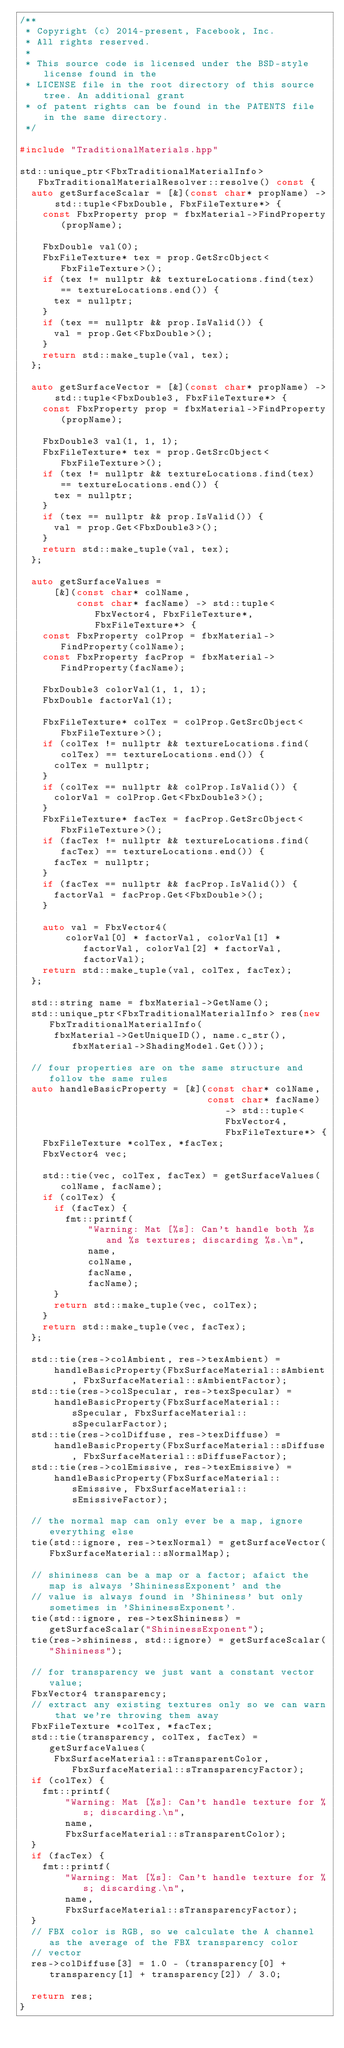Convert code to text. <code><loc_0><loc_0><loc_500><loc_500><_C++_>/**
 * Copyright (c) 2014-present, Facebook, Inc.
 * All rights reserved.
 *
 * This source code is licensed under the BSD-style license found in the
 * LICENSE file in the root directory of this source tree. An additional grant
 * of patent rights can be found in the PATENTS file in the same directory.
 */

#include "TraditionalMaterials.hpp"

std::unique_ptr<FbxTraditionalMaterialInfo> FbxTraditionalMaterialResolver::resolve() const {
  auto getSurfaceScalar = [&](const char* propName) -> std::tuple<FbxDouble, FbxFileTexture*> {
    const FbxProperty prop = fbxMaterial->FindProperty(propName);

    FbxDouble val(0);
    FbxFileTexture* tex = prop.GetSrcObject<FbxFileTexture>();
    if (tex != nullptr && textureLocations.find(tex) == textureLocations.end()) {
      tex = nullptr;
    }
    if (tex == nullptr && prop.IsValid()) {
      val = prop.Get<FbxDouble>();
    }
    return std::make_tuple(val, tex);
  };

  auto getSurfaceVector = [&](const char* propName) -> std::tuple<FbxDouble3, FbxFileTexture*> {
    const FbxProperty prop = fbxMaterial->FindProperty(propName);

    FbxDouble3 val(1, 1, 1);
    FbxFileTexture* tex = prop.GetSrcObject<FbxFileTexture>();
    if (tex != nullptr && textureLocations.find(tex) == textureLocations.end()) {
      tex = nullptr;
    }
    if (tex == nullptr && prop.IsValid()) {
      val = prop.Get<FbxDouble3>();
    }
    return std::make_tuple(val, tex);
  };

  auto getSurfaceValues =
      [&](const char* colName,
          const char* facName) -> std::tuple<FbxVector4, FbxFileTexture*, FbxFileTexture*> {
    const FbxProperty colProp = fbxMaterial->FindProperty(colName);
    const FbxProperty facProp = fbxMaterial->FindProperty(facName);

    FbxDouble3 colorVal(1, 1, 1);
    FbxDouble factorVal(1);

    FbxFileTexture* colTex = colProp.GetSrcObject<FbxFileTexture>();
    if (colTex != nullptr && textureLocations.find(colTex) == textureLocations.end()) {
      colTex = nullptr;
    }
    if (colTex == nullptr && colProp.IsValid()) {
      colorVal = colProp.Get<FbxDouble3>();
    }
    FbxFileTexture* facTex = facProp.GetSrcObject<FbxFileTexture>();
    if (facTex != nullptr && textureLocations.find(facTex) == textureLocations.end()) {
      facTex = nullptr;
    }
    if (facTex == nullptr && facProp.IsValid()) {
      factorVal = facProp.Get<FbxDouble>();
    }

    auto val = FbxVector4(
        colorVal[0] * factorVal, colorVal[1] * factorVal, colorVal[2] * factorVal, factorVal);
    return std::make_tuple(val, colTex, facTex);
  };

  std::string name = fbxMaterial->GetName();
  std::unique_ptr<FbxTraditionalMaterialInfo> res(new FbxTraditionalMaterialInfo(
      fbxMaterial->GetUniqueID(), name.c_str(), fbxMaterial->ShadingModel.Get()));

  // four properties are on the same structure and follow the same rules
  auto handleBasicProperty = [&](const char* colName,
                                 const char* facName) -> std::tuple<FbxVector4, FbxFileTexture*> {
    FbxFileTexture *colTex, *facTex;
    FbxVector4 vec;

    std::tie(vec, colTex, facTex) = getSurfaceValues(colName, facName);
    if (colTex) {
      if (facTex) {
        fmt::printf(
            "Warning: Mat [%s]: Can't handle both %s and %s textures; discarding %s.\n",
            name,
            colName,
            facName,
            facName);
      }
      return std::make_tuple(vec, colTex);
    }
    return std::make_tuple(vec, facTex);
  };

  std::tie(res->colAmbient, res->texAmbient) =
      handleBasicProperty(FbxSurfaceMaterial::sAmbient, FbxSurfaceMaterial::sAmbientFactor);
  std::tie(res->colSpecular, res->texSpecular) =
      handleBasicProperty(FbxSurfaceMaterial::sSpecular, FbxSurfaceMaterial::sSpecularFactor);
  std::tie(res->colDiffuse, res->texDiffuse) =
      handleBasicProperty(FbxSurfaceMaterial::sDiffuse, FbxSurfaceMaterial::sDiffuseFactor);
  std::tie(res->colEmissive, res->texEmissive) =
      handleBasicProperty(FbxSurfaceMaterial::sEmissive, FbxSurfaceMaterial::sEmissiveFactor);

  // the normal map can only ever be a map, ignore everything else
  tie(std::ignore, res->texNormal) = getSurfaceVector(FbxSurfaceMaterial::sNormalMap);

  // shininess can be a map or a factor; afaict the map is always 'ShininessExponent' and the
  // value is always found in 'Shininess' but only sometimes in 'ShininessExponent'.
  tie(std::ignore, res->texShininess) = getSurfaceScalar("ShininessExponent");
  tie(res->shininess, std::ignore) = getSurfaceScalar("Shininess");

  // for transparency we just want a constant vector value;
  FbxVector4 transparency;
  // extract any existing textures only so we can warn that we're throwing them away
  FbxFileTexture *colTex, *facTex;
  std::tie(transparency, colTex, facTex) = getSurfaceValues(
      FbxSurfaceMaterial::sTransparentColor, FbxSurfaceMaterial::sTransparencyFactor);
  if (colTex) {
    fmt::printf(
        "Warning: Mat [%s]: Can't handle texture for %s; discarding.\n",
        name,
        FbxSurfaceMaterial::sTransparentColor);
  }
  if (facTex) {
    fmt::printf(
        "Warning: Mat [%s]: Can't handle texture for %s; discarding.\n",
        name,
        FbxSurfaceMaterial::sTransparencyFactor);
  }
  // FBX color is RGB, so we calculate the A channel as the average of the FBX transparency color
  // vector
  res->colDiffuse[3] = 1.0 - (transparency[0] + transparency[1] + transparency[2]) / 3.0;

  return res;
}
</code> 